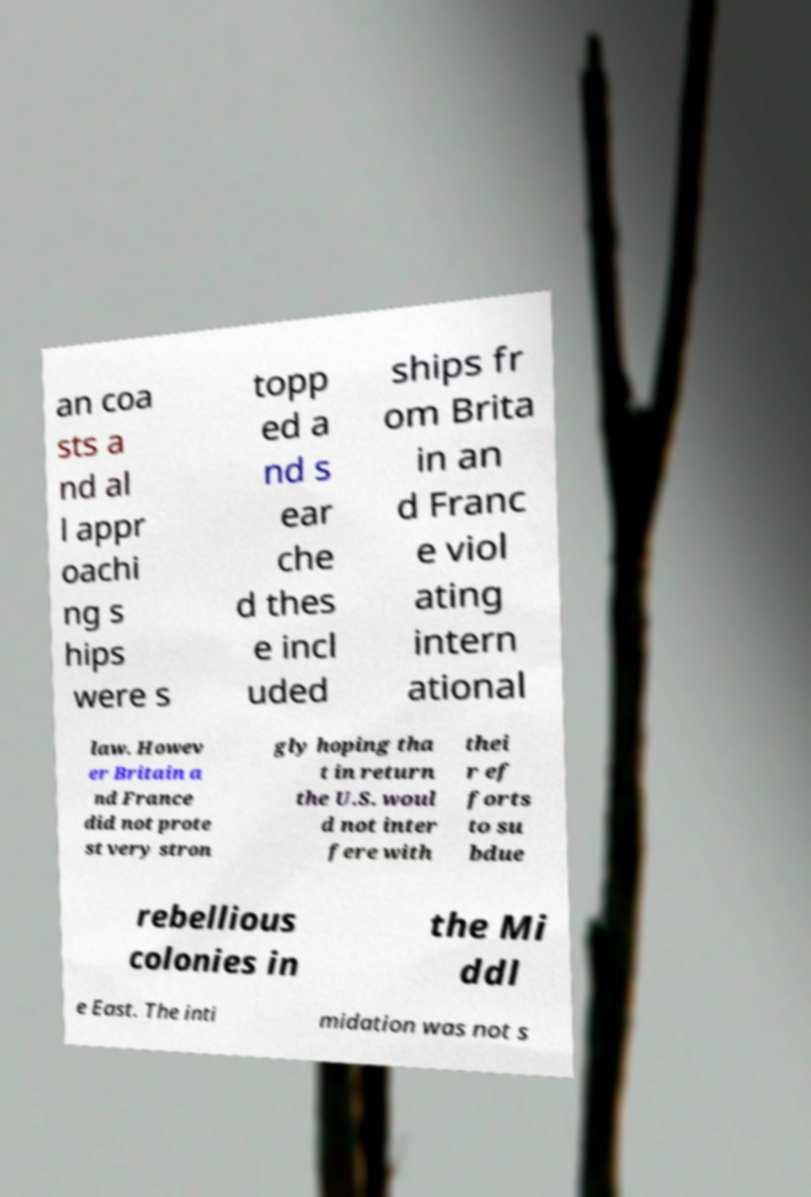Please identify and transcribe the text found in this image. an coa sts a nd al l appr oachi ng s hips were s topp ed a nd s ear che d thes e incl uded ships fr om Brita in an d Franc e viol ating intern ational law. Howev er Britain a nd France did not prote st very stron gly hoping tha t in return the U.S. woul d not inter fere with thei r ef forts to su bdue rebellious colonies in the Mi ddl e East. The inti midation was not s 